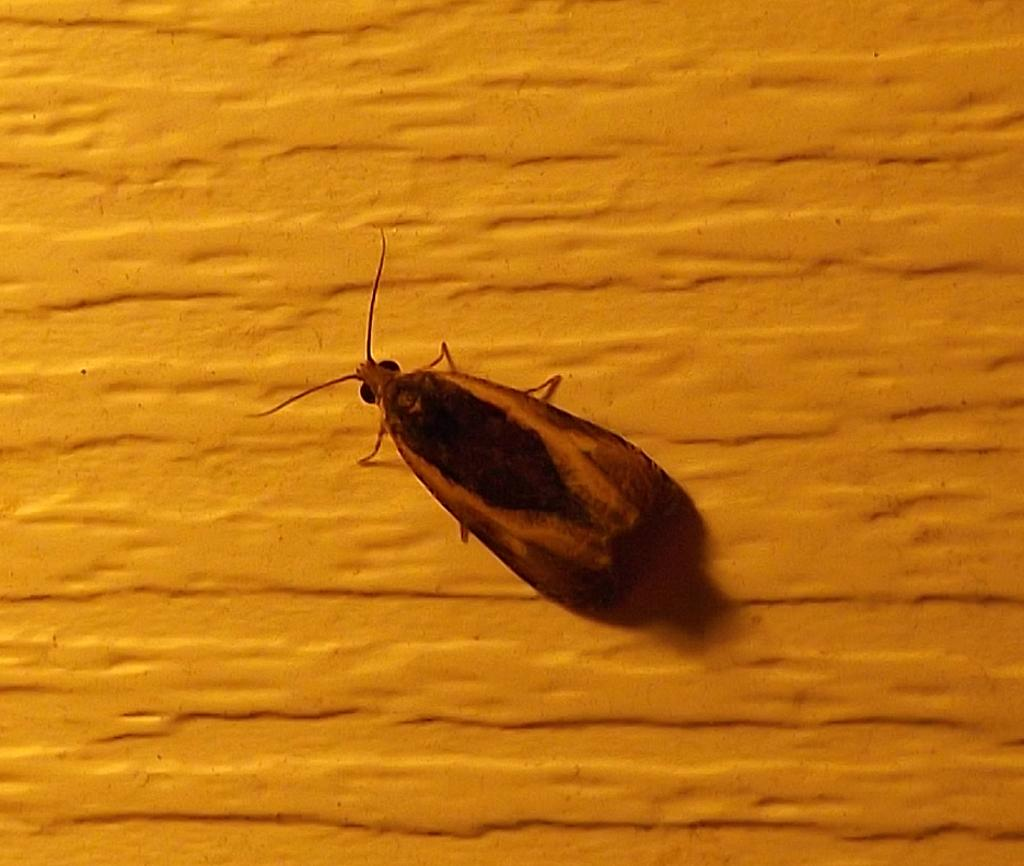What is the main subject in the center of the image? There is a cockroach in the center of the image. What can be seen in the background of the image? There is a wall in the background of the image. Reasoning: Let' Let's think step by step in order to produce the conversation. We start by identifying the main subject in the image, which is the cockroach. Then, we expand the conversation to include the background, which is a wall. Each question is designed to elicit a specific detail about the image that is known from the provided facts. Absurd Question/Answer: How many boats are visible in the harbor in the image? There is no harbor or boats present in the image; it features a cockroach and a wall. 